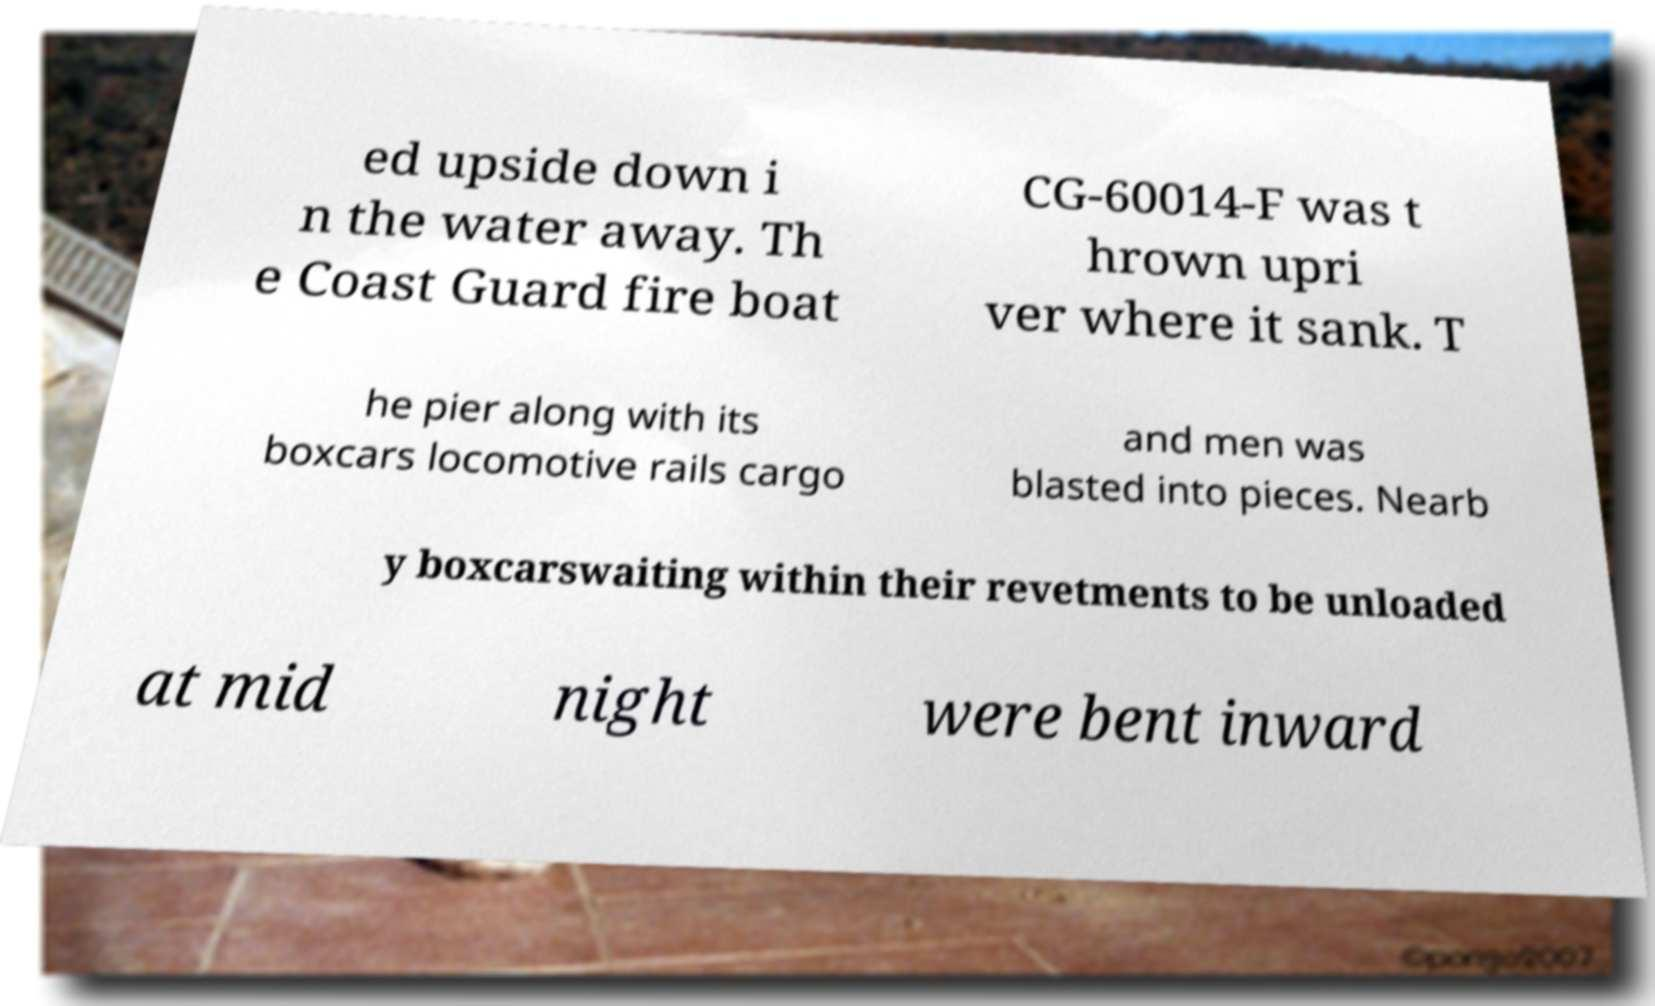I need the written content from this picture converted into text. Can you do that? ed upside down i n the water away. Th e Coast Guard fire boat CG-60014-F was t hrown upri ver where it sank. T he pier along with its boxcars locomotive rails cargo and men was blasted into pieces. Nearb y boxcarswaiting within their revetments to be unloaded at mid night were bent inward 